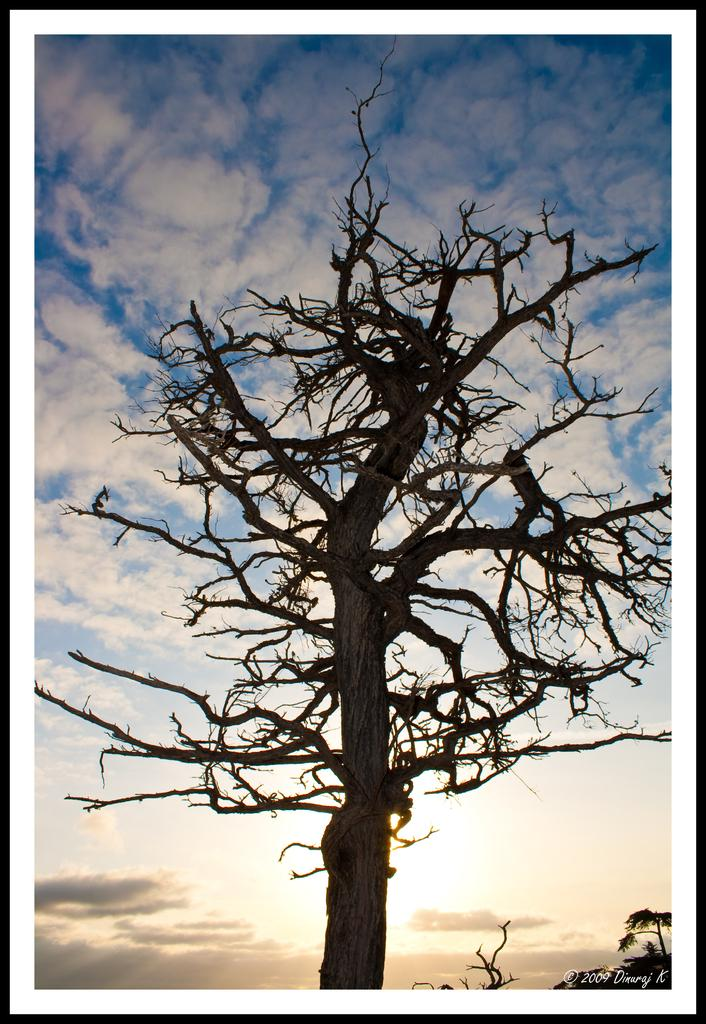What type of vegetation can be seen in the image? There are trees in the image. What part of the natural environment is visible in the image? The sky is visible in the image. What can be observed in the sky? Clouds are present in the sky. Where is the text located in the image? The text is in the bottom right corner of the image. What type of credit can be seen in the image? There is no credit present in the image; it only contains trees, the sky, clouds, and text in the bottom right corner. How many times does the image need to be folded to fit into a small envelope? The image cannot be folded, as it is a digital representation or a photograph. 